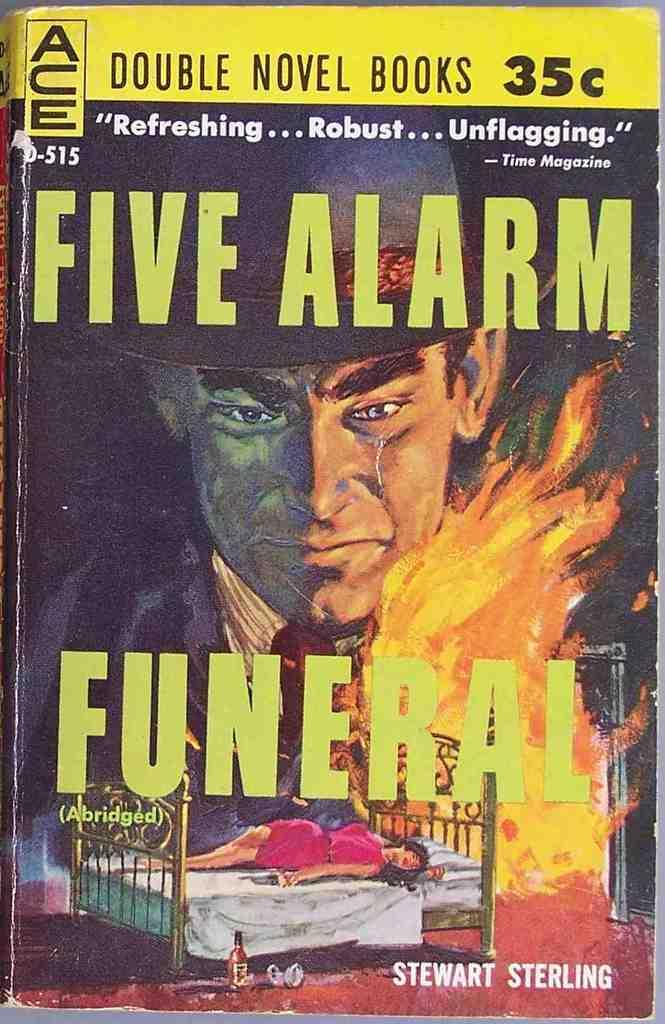Provide a one-sentence caption for the provided image. A book by the name of Five Alarm Funeral. 